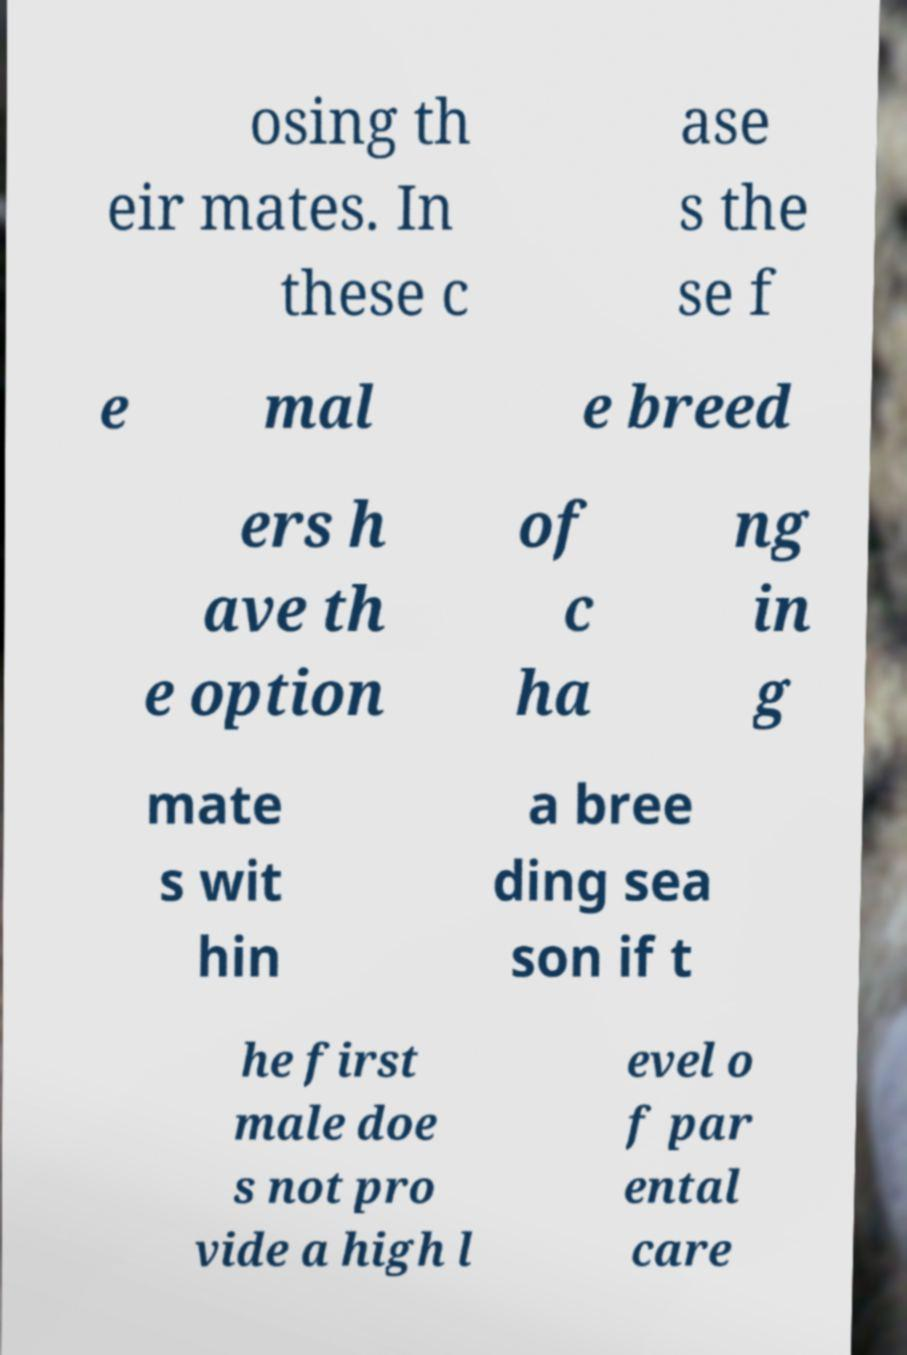Please identify and transcribe the text found in this image. osing th eir mates. In these c ase s the se f e mal e breed ers h ave th e option of c ha ng in g mate s wit hin a bree ding sea son if t he first male doe s not pro vide a high l evel o f par ental care 